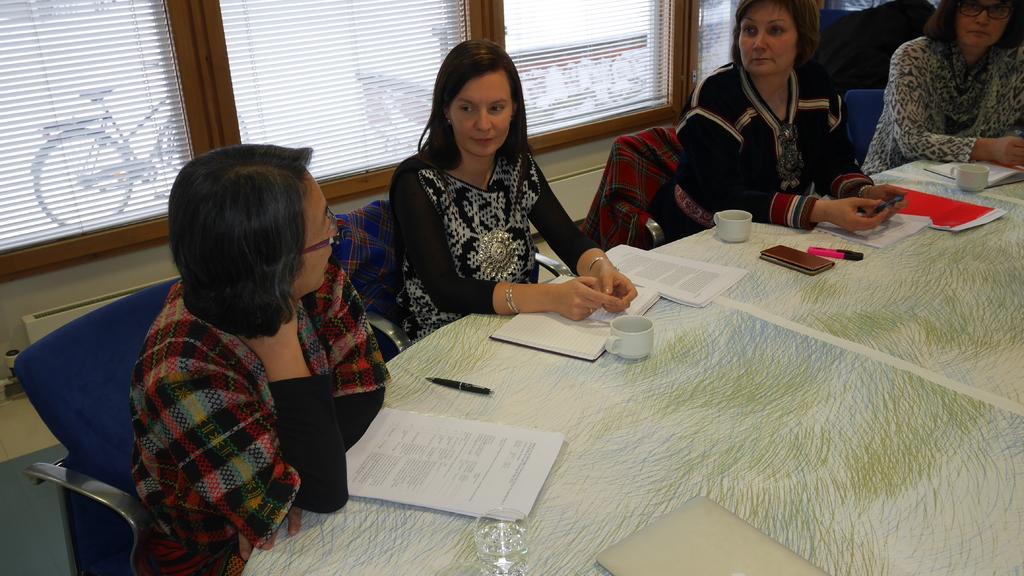Describe this image in one or two sentences. In the image there are many women in sweat shirt sitting around table with coffee cups,books,pens,marker and cell phone on it, behind them there is window with curtains on the wall and outside the window a bicycle visible. 